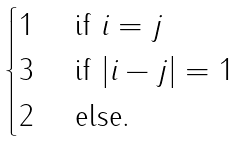Convert formula to latex. <formula><loc_0><loc_0><loc_500><loc_500>\begin{cases} 1 & \text { if } i = j \\ 3 & \text { if } | i - j | = 1 \\ 2 & \text { else.} \end{cases}</formula> 